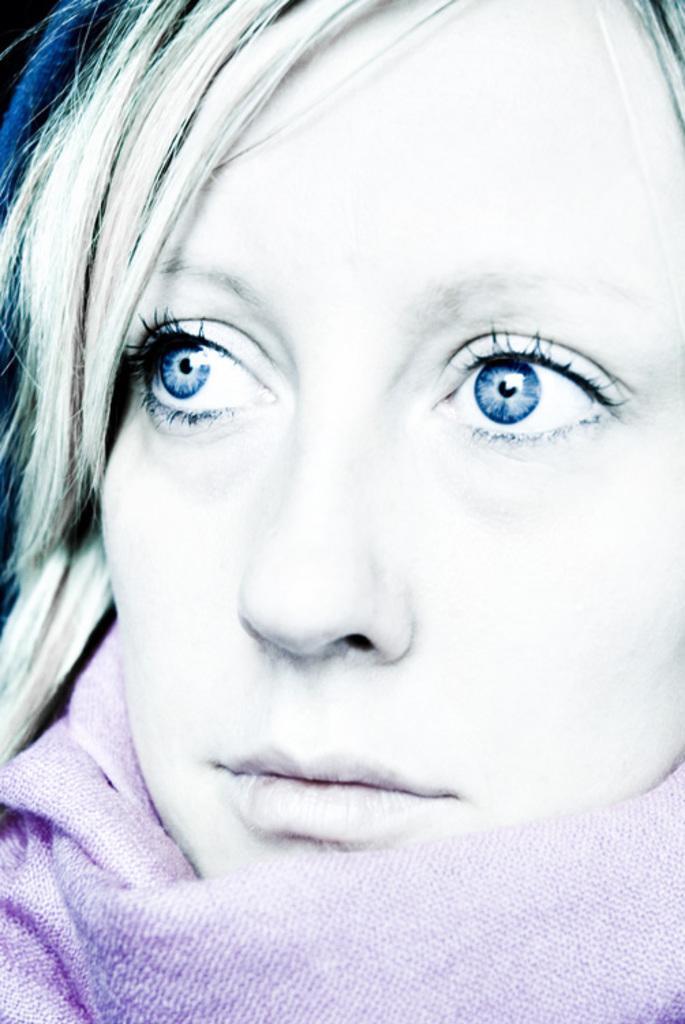Describe this image in one or two sentences. In this image, we can see a woman wearing a scarf. 